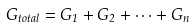Convert formula to latex. <formula><loc_0><loc_0><loc_500><loc_500>G _ { t o t a l } = G _ { 1 } + G _ { 2 } + \cdots + G _ { n }</formula> 